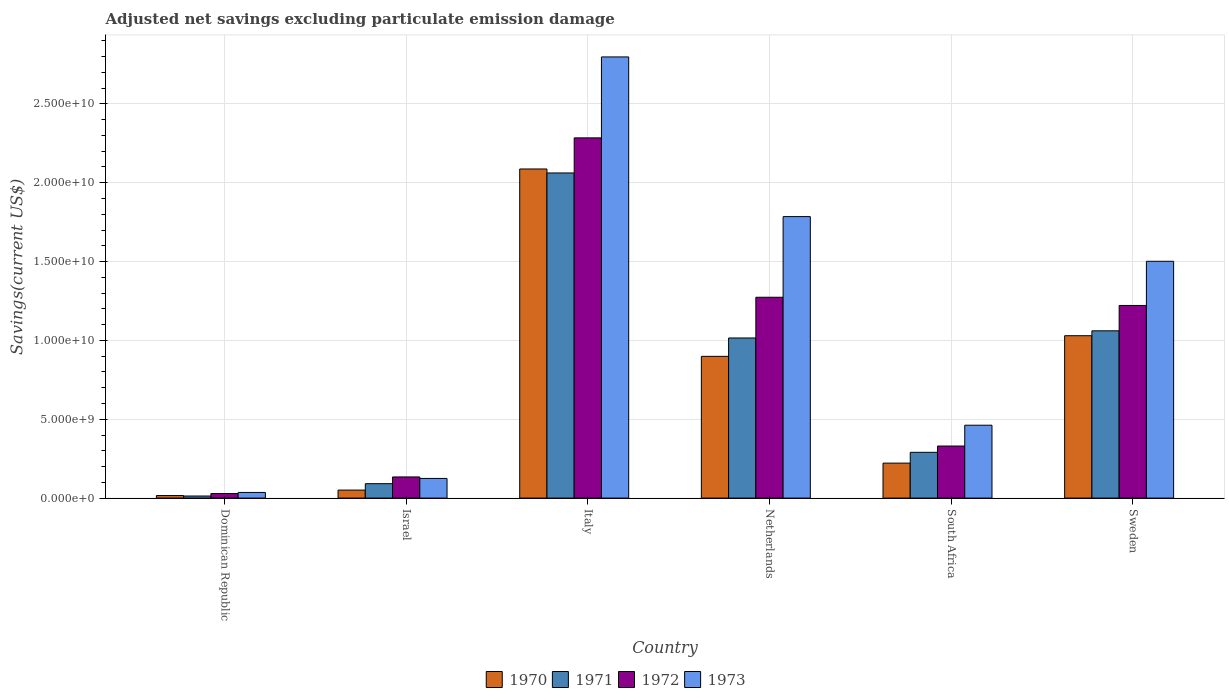How many different coloured bars are there?
Your response must be concise. 4. How many groups of bars are there?
Offer a terse response. 6. Are the number of bars on each tick of the X-axis equal?
Ensure brevity in your answer.  Yes. How many bars are there on the 2nd tick from the left?
Provide a succinct answer. 4. How many bars are there on the 4th tick from the right?
Offer a terse response. 4. What is the label of the 5th group of bars from the left?
Your answer should be very brief. South Africa. What is the adjusted net savings in 1970 in Netherlands?
Your answer should be compact. 8.99e+09. Across all countries, what is the maximum adjusted net savings in 1973?
Give a very brief answer. 2.80e+1. Across all countries, what is the minimum adjusted net savings in 1972?
Keep it short and to the point. 2.89e+08. In which country was the adjusted net savings in 1971 minimum?
Provide a succinct answer. Dominican Republic. What is the total adjusted net savings in 1973 in the graph?
Provide a short and direct response. 6.71e+1. What is the difference between the adjusted net savings in 1973 in Dominican Republic and that in Israel?
Your response must be concise. -8.89e+08. What is the difference between the adjusted net savings in 1972 in Dominican Republic and the adjusted net savings in 1971 in Israel?
Offer a very short reply. -6.26e+08. What is the average adjusted net savings in 1970 per country?
Ensure brevity in your answer.  7.17e+09. What is the difference between the adjusted net savings of/in 1973 and adjusted net savings of/in 1971 in Sweden?
Make the answer very short. 4.41e+09. In how many countries, is the adjusted net savings in 1973 greater than 13000000000 US$?
Your answer should be very brief. 3. What is the ratio of the adjusted net savings in 1970 in Italy to that in South Africa?
Give a very brief answer. 9.41. Is the adjusted net savings in 1971 in Italy less than that in South Africa?
Ensure brevity in your answer.  No. What is the difference between the highest and the second highest adjusted net savings in 1970?
Ensure brevity in your answer.  1.06e+1. What is the difference between the highest and the lowest adjusted net savings in 1972?
Keep it short and to the point. 2.26e+1. In how many countries, is the adjusted net savings in 1970 greater than the average adjusted net savings in 1970 taken over all countries?
Make the answer very short. 3. What does the 2nd bar from the left in Italy represents?
Your response must be concise. 1971. What does the 3rd bar from the right in Israel represents?
Offer a very short reply. 1971. Are all the bars in the graph horizontal?
Provide a short and direct response. No. How many countries are there in the graph?
Make the answer very short. 6. Does the graph contain any zero values?
Ensure brevity in your answer.  No. How are the legend labels stacked?
Keep it short and to the point. Horizontal. What is the title of the graph?
Provide a short and direct response. Adjusted net savings excluding particulate emission damage. What is the label or title of the Y-axis?
Offer a very short reply. Savings(current US$). What is the Savings(current US$) of 1970 in Dominican Republic?
Give a very brief answer. 1.61e+08. What is the Savings(current US$) in 1971 in Dominican Republic?
Make the answer very short. 1.32e+08. What is the Savings(current US$) in 1972 in Dominican Republic?
Your answer should be very brief. 2.89e+08. What is the Savings(current US$) of 1973 in Dominican Republic?
Your answer should be very brief. 3.58e+08. What is the Savings(current US$) of 1970 in Israel?
Make the answer very short. 5.08e+08. What is the Savings(current US$) of 1971 in Israel?
Keep it short and to the point. 9.14e+08. What is the Savings(current US$) of 1972 in Israel?
Offer a terse response. 1.34e+09. What is the Savings(current US$) in 1973 in Israel?
Keep it short and to the point. 1.25e+09. What is the Savings(current US$) in 1970 in Italy?
Ensure brevity in your answer.  2.09e+1. What is the Savings(current US$) in 1971 in Italy?
Keep it short and to the point. 2.06e+1. What is the Savings(current US$) of 1972 in Italy?
Your response must be concise. 2.28e+1. What is the Savings(current US$) of 1973 in Italy?
Give a very brief answer. 2.80e+1. What is the Savings(current US$) in 1970 in Netherlands?
Offer a terse response. 8.99e+09. What is the Savings(current US$) in 1971 in Netherlands?
Give a very brief answer. 1.02e+1. What is the Savings(current US$) of 1972 in Netherlands?
Offer a very short reply. 1.27e+1. What is the Savings(current US$) of 1973 in Netherlands?
Your response must be concise. 1.79e+1. What is the Savings(current US$) in 1970 in South Africa?
Provide a succinct answer. 2.22e+09. What is the Savings(current US$) of 1971 in South Africa?
Ensure brevity in your answer.  2.90e+09. What is the Savings(current US$) of 1972 in South Africa?
Ensure brevity in your answer.  3.30e+09. What is the Savings(current US$) in 1973 in South Africa?
Give a very brief answer. 4.62e+09. What is the Savings(current US$) of 1970 in Sweden?
Your response must be concise. 1.03e+1. What is the Savings(current US$) of 1971 in Sweden?
Give a very brief answer. 1.06e+1. What is the Savings(current US$) of 1972 in Sweden?
Your answer should be compact. 1.22e+1. What is the Savings(current US$) of 1973 in Sweden?
Give a very brief answer. 1.50e+1. Across all countries, what is the maximum Savings(current US$) in 1970?
Provide a short and direct response. 2.09e+1. Across all countries, what is the maximum Savings(current US$) in 1971?
Provide a short and direct response. 2.06e+1. Across all countries, what is the maximum Savings(current US$) of 1972?
Your response must be concise. 2.28e+1. Across all countries, what is the maximum Savings(current US$) of 1973?
Make the answer very short. 2.80e+1. Across all countries, what is the minimum Savings(current US$) of 1970?
Your answer should be very brief. 1.61e+08. Across all countries, what is the minimum Savings(current US$) of 1971?
Make the answer very short. 1.32e+08. Across all countries, what is the minimum Savings(current US$) in 1972?
Your response must be concise. 2.89e+08. Across all countries, what is the minimum Savings(current US$) in 1973?
Make the answer very short. 3.58e+08. What is the total Savings(current US$) of 1970 in the graph?
Provide a succinct answer. 4.30e+1. What is the total Savings(current US$) in 1971 in the graph?
Your answer should be compact. 4.53e+1. What is the total Savings(current US$) of 1972 in the graph?
Give a very brief answer. 5.27e+1. What is the total Savings(current US$) in 1973 in the graph?
Your answer should be compact. 6.71e+1. What is the difference between the Savings(current US$) of 1970 in Dominican Republic and that in Israel?
Offer a very short reply. -3.47e+08. What is the difference between the Savings(current US$) in 1971 in Dominican Republic and that in Israel?
Offer a very short reply. -7.83e+08. What is the difference between the Savings(current US$) in 1972 in Dominican Republic and that in Israel?
Provide a succinct answer. -1.05e+09. What is the difference between the Savings(current US$) of 1973 in Dominican Republic and that in Israel?
Keep it short and to the point. -8.89e+08. What is the difference between the Savings(current US$) of 1970 in Dominican Republic and that in Italy?
Your answer should be compact. -2.07e+1. What is the difference between the Savings(current US$) in 1971 in Dominican Republic and that in Italy?
Offer a terse response. -2.05e+1. What is the difference between the Savings(current US$) of 1972 in Dominican Republic and that in Italy?
Your answer should be compact. -2.26e+1. What is the difference between the Savings(current US$) of 1973 in Dominican Republic and that in Italy?
Provide a short and direct response. -2.76e+1. What is the difference between the Savings(current US$) of 1970 in Dominican Republic and that in Netherlands?
Give a very brief answer. -8.83e+09. What is the difference between the Savings(current US$) in 1971 in Dominican Republic and that in Netherlands?
Keep it short and to the point. -1.00e+1. What is the difference between the Savings(current US$) in 1972 in Dominican Republic and that in Netherlands?
Provide a succinct answer. -1.24e+1. What is the difference between the Savings(current US$) in 1973 in Dominican Republic and that in Netherlands?
Provide a short and direct response. -1.75e+1. What is the difference between the Savings(current US$) in 1970 in Dominican Republic and that in South Africa?
Give a very brief answer. -2.06e+09. What is the difference between the Savings(current US$) in 1971 in Dominican Republic and that in South Africa?
Your answer should be compact. -2.77e+09. What is the difference between the Savings(current US$) of 1972 in Dominican Republic and that in South Africa?
Offer a very short reply. -3.01e+09. What is the difference between the Savings(current US$) in 1973 in Dominican Republic and that in South Africa?
Ensure brevity in your answer.  -4.26e+09. What is the difference between the Savings(current US$) of 1970 in Dominican Republic and that in Sweden?
Make the answer very short. -1.01e+1. What is the difference between the Savings(current US$) of 1971 in Dominican Republic and that in Sweden?
Make the answer very short. -1.05e+1. What is the difference between the Savings(current US$) in 1972 in Dominican Republic and that in Sweden?
Ensure brevity in your answer.  -1.19e+1. What is the difference between the Savings(current US$) of 1973 in Dominican Republic and that in Sweden?
Provide a succinct answer. -1.47e+1. What is the difference between the Savings(current US$) in 1970 in Israel and that in Italy?
Provide a succinct answer. -2.04e+1. What is the difference between the Savings(current US$) of 1971 in Israel and that in Italy?
Give a very brief answer. -1.97e+1. What is the difference between the Savings(current US$) of 1972 in Israel and that in Italy?
Ensure brevity in your answer.  -2.15e+1. What is the difference between the Savings(current US$) of 1973 in Israel and that in Italy?
Offer a terse response. -2.67e+1. What is the difference between the Savings(current US$) in 1970 in Israel and that in Netherlands?
Ensure brevity in your answer.  -8.48e+09. What is the difference between the Savings(current US$) of 1971 in Israel and that in Netherlands?
Ensure brevity in your answer.  -9.24e+09. What is the difference between the Savings(current US$) in 1972 in Israel and that in Netherlands?
Provide a succinct answer. -1.14e+1. What is the difference between the Savings(current US$) in 1973 in Israel and that in Netherlands?
Your answer should be compact. -1.66e+1. What is the difference between the Savings(current US$) of 1970 in Israel and that in South Africa?
Provide a succinct answer. -1.71e+09. What is the difference between the Savings(current US$) in 1971 in Israel and that in South Africa?
Keep it short and to the point. -1.99e+09. What is the difference between the Savings(current US$) of 1972 in Israel and that in South Africa?
Provide a short and direct response. -1.96e+09. What is the difference between the Savings(current US$) of 1973 in Israel and that in South Africa?
Offer a terse response. -3.38e+09. What is the difference between the Savings(current US$) in 1970 in Israel and that in Sweden?
Give a very brief answer. -9.79e+09. What is the difference between the Savings(current US$) of 1971 in Israel and that in Sweden?
Provide a short and direct response. -9.69e+09. What is the difference between the Savings(current US$) in 1972 in Israel and that in Sweden?
Your answer should be compact. -1.09e+1. What is the difference between the Savings(current US$) in 1973 in Israel and that in Sweden?
Provide a short and direct response. -1.38e+1. What is the difference between the Savings(current US$) of 1970 in Italy and that in Netherlands?
Offer a terse response. 1.19e+1. What is the difference between the Savings(current US$) of 1971 in Italy and that in Netherlands?
Your answer should be very brief. 1.05e+1. What is the difference between the Savings(current US$) in 1972 in Italy and that in Netherlands?
Offer a terse response. 1.01e+1. What is the difference between the Savings(current US$) in 1973 in Italy and that in Netherlands?
Provide a succinct answer. 1.01e+1. What is the difference between the Savings(current US$) of 1970 in Italy and that in South Africa?
Offer a very short reply. 1.87e+1. What is the difference between the Savings(current US$) of 1971 in Italy and that in South Africa?
Make the answer very short. 1.77e+1. What is the difference between the Savings(current US$) in 1972 in Italy and that in South Africa?
Your response must be concise. 1.95e+1. What is the difference between the Savings(current US$) in 1973 in Italy and that in South Africa?
Offer a terse response. 2.34e+1. What is the difference between the Savings(current US$) in 1970 in Italy and that in Sweden?
Offer a very short reply. 1.06e+1. What is the difference between the Savings(current US$) in 1971 in Italy and that in Sweden?
Provide a succinct answer. 1.00e+1. What is the difference between the Savings(current US$) in 1972 in Italy and that in Sweden?
Offer a very short reply. 1.06e+1. What is the difference between the Savings(current US$) of 1973 in Italy and that in Sweden?
Your answer should be compact. 1.30e+1. What is the difference between the Savings(current US$) in 1970 in Netherlands and that in South Africa?
Your answer should be very brief. 6.77e+09. What is the difference between the Savings(current US$) of 1971 in Netherlands and that in South Africa?
Give a very brief answer. 7.25e+09. What is the difference between the Savings(current US$) of 1972 in Netherlands and that in South Africa?
Offer a terse response. 9.43e+09. What is the difference between the Savings(current US$) in 1973 in Netherlands and that in South Africa?
Keep it short and to the point. 1.32e+1. What is the difference between the Savings(current US$) in 1970 in Netherlands and that in Sweden?
Ensure brevity in your answer.  -1.31e+09. What is the difference between the Savings(current US$) in 1971 in Netherlands and that in Sweden?
Ensure brevity in your answer.  -4.54e+08. What is the difference between the Savings(current US$) in 1972 in Netherlands and that in Sweden?
Your answer should be very brief. 5.20e+08. What is the difference between the Savings(current US$) in 1973 in Netherlands and that in Sweden?
Your answer should be very brief. 2.83e+09. What is the difference between the Savings(current US$) of 1970 in South Africa and that in Sweden?
Your answer should be very brief. -8.08e+09. What is the difference between the Savings(current US$) of 1971 in South Africa and that in Sweden?
Provide a short and direct response. -7.70e+09. What is the difference between the Savings(current US$) in 1972 in South Africa and that in Sweden?
Ensure brevity in your answer.  -8.91e+09. What is the difference between the Savings(current US$) in 1973 in South Africa and that in Sweden?
Offer a terse response. -1.04e+1. What is the difference between the Savings(current US$) in 1970 in Dominican Republic and the Savings(current US$) in 1971 in Israel?
Your answer should be very brief. -7.53e+08. What is the difference between the Savings(current US$) of 1970 in Dominican Republic and the Savings(current US$) of 1972 in Israel?
Your answer should be compact. -1.18e+09. What is the difference between the Savings(current US$) of 1970 in Dominican Republic and the Savings(current US$) of 1973 in Israel?
Keep it short and to the point. -1.09e+09. What is the difference between the Savings(current US$) in 1971 in Dominican Republic and the Savings(current US$) in 1972 in Israel?
Your response must be concise. -1.21e+09. What is the difference between the Savings(current US$) of 1971 in Dominican Republic and the Savings(current US$) of 1973 in Israel?
Your answer should be very brief. -1.12e+09. What is the difference between the Savings(current US$) of 1972 in Dominican Republic and the Savings(current US$) of 1973 in Israel?
Give a very brief answer. -9.58e+08. What is the difference between the Savings(current US$) in 1970 in Dominican Republic and the Savings(current US$) in 1971 in Italy?
Offer a terse response. -2.05e+1. What is the difference between the Savings(current US$) of 1970 in Dominican Republic and the Savings(current US$) of 1972 in Italy?
Your answer should be compact. -2.27e+1. What is the difference between the Savings(current US$) in 1970 in Dominican Republic and the Savings(current US$) in 1973 in Italy?
Your response must be concise. -2.78e+1. What is the difference between the Savings(current US$) in 1971 in Dominican Republic and the Savings(current US$) in 1972 in Italy?
Your answer should be compact. -2.27e+1. What is the difference between the Savings(current US$) in 1971 in Dominican Republic and the Savings(current US$) in 1973 in Italy?
Your response must be concise. -2.78e+1. What is the difference between the Savings(current US$) of 1972 in Dominican Republic and the Savings(current US$) of 1973 in Italy?
Make the answer very short. -2.77e+1. What is the difference between the Savings(current US$) of 1970 in Dominican Republic and the Savings(current US$) of 1971 in Netherlands?
Provide a short and direct response. -9.99e+09. What is the difference between the Savings(current US$) in 1970 in Dominican Republic and the Savings(current US$) in 1972 in Netherlands?
Ensure brevity in your answer.  -1.26e+1. What is the difference between the Savings(current US$) of 1970 in Dominican Republic and the Savings(current US$) of 1973 in Netherlands?
Make the answer very short. -1.77e+1. What is the difference between the Savings(current US$) of 1971 in Dominican Republic and the Savings(current US$) of 1972 in Netherlands?
Your response must be concise. -1.26e+1. What is the difference between the Savings(current US$) of 1971 in Dominican Republic and the Savings(current US$) of 1973 in Netherlands?
Provide a succinct answer. -1.77e+1. What is the difference between the Savings(current US$) of 1972 in Dominican Republic and the Savings(current US$) of 1973 in Netherlands?
Offer a terse response. -1.76e+1. What is the difference between the Savings(current US$) in 1970 in Dominican Republic and the Savings(current US$) in 1971 in South Africa?
Offer a very short reply. -2.74e+09. What is the difference between the Savings(current US$) of 1970 in Dominican Republic and the Savings(current US$) of 1972 in South Africa?
Offer a terse response. -3.14e+09. What is the difference between the Savings(current US$) in 1970 in Dominican Republic and the Savings(current US$) in 1973 in South Africa?
Offer a terse response. -4.46e+09. What is the difference between the Savings(current US$) in 1971 in Dominican Republic and the Savings(current US$) in 1972 in South Africa?
Your response must be concise. -3.17e+09. What is the difference between the Savings(current US$) of 1971 in Dominican Republic and the Savings(current US$) of 1973 in South Africa?
Give a very brief answer. -4.49e+09. What is the difference between the Savings(current US$) of 1972 in Dominican Republic and the Savings(current US$) of 1973 in South Africa?
Make the answer very short. -4.33e+09. What is the difference between the Savings(current US$) of 1970 in Dominican Republic and the Savings(current US$) of 1971 in Sweden?
Offer a terse response. -1.04e+1. What is the difference between the Savings(current US$) of 1970 in Dominican Republic and the Savings(current US$) of 1972 in Sweden?
Your response must be concise. -1.21e+1. What is the difference between the Savings(current US$) of 1970 in Dominican Republic and the Savings(current US$) of 1973 in Sweden?
Your response must be concise. -1.49e+1. What is the difference between the Savings(current US$) in 1971 in Dominican Republic and the Savings(current US$) in 1972 in Sweden?
Ensure brevity in your answer.  -1.21e+1. What is the difference between the Savings(current US$) of 1971 in Dominican Republic and the Savings(current US$) of 1973 in Sweden?
Keep it short and to the point. -1.49e+1. What is the difference between the Savings(current US$) in 1972 in Dominican Republic and the Savings(current US$) in 1973 in Sweden?
Offer a terse response. -1.47e+1. What is the difference between the Savings(current US$) in 1970 in Israel and the Savings(current US$) in 1971 in Italy?
Your response must be concise. -2.01e+1. What is the difference between the Savings(current US$) in 1970 in Israel and the Savings(current US$) in 1972 in Italy?
Your response must be concise. -2.23e+1. What is the difference between the Savings(current US$) in 1970 in Israel and the Savings(current US$) in 1973 in Italy?
Keep it short and to the point. -2.75e+1. What is the difference between the Savings(current US$) in 1971 in Israel and the Savings(current US$) in 1972 in Italy?
Make the answer very short. -2.19e+1. What is the difference between the Savings(current US$) in 1971 in Israel and the Savings(current US$) in 1973 in Italy?
Give a very brief answer. -2.71e+1. What is the difference between the Savings(current US$) of 1972 in Israel and the Savings(current US$) of 1973 in Italy?
Your answer should be compact. -2.66e+1. What is the difference between the Savings(current US$) in 1970 in Israel and the Savings(current US$) in 1971 in Netherlands?
Offer a terse response. -9.65e+09. What is the difference between the Savings(current US$) in 1970 in Israel and the Savings(current US$) in 1972 in Netherlands?
Your response must be concise. -1.22e+1. What is the difference between the Savings(current US$) of 1970 in Israel and the Savings(current US$) of 1973 in Netherlands?
Make the answer very short. -1.73e+1. What is the difference between the Savings(current US$) of 1971 in Israel and the Savings(current US$) of 1972 in Netherlands?
Offer a very short reply. -1.18e+1. What is the difference between the Savings(current US$) in 1971 in Israel and the Savings(current US$) in 1973 in Netherlands?
Offer a terse response. -1.69e+1. What is the difference between the Savings(current US$) of 1972 in Israel and the Savings(current US$) of 1973 in Netherlands?
Offer a very short reply. -1.65e+1. What is the difference between the Savings(current US$) of 1970 in Israel and the Savings(current US$) of 1971 in South Africa?
Ensure brevity in your answer.  -2.39e+09. What is the difference between the Savings(current US$) of 1970 in Israel and the Savings(current US$) of 1972 in South Africa?
Provide a short and direct response. -2.79e+09. What is the difference between the Savings(current US$) of 1970 in Israel and the Savings(current US$) of 1973 in South Africa?
Make the answer very short. -4.11e+09. What is the difference between the Savings(current US$) of 1971 in Israel and the Savings(current US$) of 1972 in South Africa?
Ensure brevity in your answer.  -2.39e+09. What is the difference between the Savings(current US$) in 1971 in Israel and the Savings(current US$) in 1973 in South Africa?
Your answer should be compact. -3.71e+09. What is the difference between the Savings(current US$) of 1972 in Israel and the Savings(current US$) of 1973 in South Africa?
Keep it short and to the point. -3.28e+09. What is the difference between the Savings(current US$) of 1970 in Israel and the Savings(current US$) of 1971 in Sweden?
Provide a short and direct response. -1.01e+1. What is the difference between the Savings(current US$) in 1970 in Israel and the Savings(current US$) in 1972 in Sweden?
Provide a succinct answer. -1.17e+1. What is the difference between the Savings(current US$) of 1970 in Israel and the Savings(current US$) of 1973 in Sweden?
Give a very brief answer. -1.45e+1. What is the difference between the Savings(current US$) of 1971 in Israel and the Savings(current US$) of 1972 in Sweden?
Offer a terse response. -1.13e+1. What is the difference between the Savings(current US$) in 1971 in Israel and the Savings(current US$) in 1973 in Sweden?
Provide a short and direct response. -1.41e+1. What is the difference between the Savings(current US$) in 1972 in Israel and the Savings(current US$) in 1973 in Sweden?
Give a very brief answer. -1.37e+1. What is the difference between the Savings(current US$) in 1970 in Italy and the Savings(current US$) in 1971 in Netherlands?
Provide a succinct answer. 1.07e+1. What is the difference between the Savings(current US$) of 1970 in Italy and the Savings(current US$) of 1972 in Netherlands?
Offer a terse response. 8.14e+09. What is the difference between the Savings(current US$) of 1970 in Italy and the Savings(current US$) of 1973 in Netherlands?
Make the answer very short. 3.02e+09. What is the difference between the Savings(current US$) in 1971 in Italy and the Savings(current US$) in 1972 in Netherlands?
Your answer should be compact. 7.88e+09. What is the difference between the Savings(current US$) of 1971 in Italy and the Savings(current US$) of 1973 in Netherlands?
Provide a succinct answer. 2.77e+09. What is the difference between the Savings(current US$) of 1972 in Italy and the Savings(current US$) of 1973 in Netherlands?
Offer a terse response. 4.99e+09. What is the difference between the Savings(current US$) of 1970 in Italy and the Savings(current US$) of 1971 in South Africa?
Keep it short and to the point. 1.80e+1. What is the difference between the Savings(current US$) in 1970 in Italy and the Savings(current US$) in 1972 in South Africa?
Ensure brevity in your answer.  1.76e+1. What is the difference between the Savings(current US$) in 1970 in Italy and the Savings(current US$) in 1973 in South Africa?
Keep it short and to the point. 1.62e+1. What is the difference between the Savings(current US$) in 1971 in Italy and the Savings(current US$) in 1972 in South Africa?
Your answer should be very brief. 1.73e+1. What is the difference between the Savings(current US$) of 1971 in Italy and the Savings(current US$) of 1973 in South Africa?
Offer a very short reply. 1.60e+1. What is the difference between the Savings(current US$) of 1972 in Italy and the Savings(current US$) of 1973 in South Africa?
Make the answer very short. 1.82e+1. What is the difference between the Savings(current US$) of 1970 in Italy and the Savings(current US$) of 1971 in Sweden?
Make the answer very short. 1.03e+1. What is the difference between the Savings(current US$) of 1970 in Italy and the Savings(current US$) of 1972 in Sweden?
Your answer should be compact. 8.66e+09. What is the difference between the Savings(current US$) in 1970 in Italy and the Savings(current US$) in 1973 in Sweden?
Provide a succinct answer. 5.85e+09. What is the difference between the Savings(current US$) in 1971 in Italy and the Savings(current US$) in 1972 in Sweden?
Make the answer very short. 8.40e+09. What is the difference between the Savings(current US$) in 1971 in Italy and the Savings(current US$) in 1973 in Sweden?
Offer a terse response. 5.60e+09. What is the difference between the Savings(current US$) of 1972 in Italy and the Savings(current US$) of 1973 in Sweden?
Your answer should be very brief. 7.83e+09. What is the difference between the Savings(current US$) in 1970 in Netherlands and the Savings(current US$) in 1971 in South Africa?
Make the answer very short. 6.09e+09. What is the difference between the Savings(current US$) in 1970 in Netherlands and the Savings(current US$) in 1972 in South Africa?
Your response must be concise. 5.69e+09. What is the difference between the Savings(current US$) in 1970 in Netherlands and the Savings(current US$) in 1973 in South Africa?
Your response must be concise. 4.37e+09. What is the difference between the Savings(current US$) in 1971 in Netherlands and the Savings(current US$) in 1972 in South Africa?
Give a very brief answer. 6.85e+09. What is the difference between the Savings(current US$) of 1971 in Netherlands and the Savings(current US$) of 1973 in South Africa?
Your answer should be compact. 5.53e+09. What is the difference between the Savings(current US$) in 1972 in Netherlands and the Savings(current US$) in 1973 in South Africa?
Ensure brevity in your answer.  8.11e+09. What is the difference between the Savings(current US$) of 1970 in Netherlands and the Savings(current US$) of 1971 in Sweden?
Make the answer very short. -1.62e+09. What is the difference between the Savings(current US$) in 1970 in Netherlands and the Savings(current US$) in 1972 in Sweden?
Provide a succinct answer. -3.23e+09. What is the difference between the Savings(current US$) in 1970 in Netherlands and the Savings(current US$) in 1973 in Sweden?
Your answer should be very brief. -6.03e+09. What is the difference between the Savings(current US$) in 1971 in Netherlands and the Savings(current US$) in 1972 in Sweden?
Ensure brevity in your answer.  -2.06e+09. What is the difference between the Savings(current US$) of 1971 in Netherlands and the Savings(current US$) of 1973 in Sweden?
Offer a very short reply. -4.86e+09. What is the difference between the Savings(current US$) of 1972 in Netherlands and the Savings(current US$) of 1973 in Sweden?
Your response must be concise. -2.28e+09. What is the difference between the Savings(current US$) of 1970 in South Africa and the Savings(current US$) of 1971 in Sweden?
Offer a terse response. -8.39e+09. What is the difference between the Savings(current US$) of 1970 in South Africa and the Savings(current US$) of 1972 in Sweden?
Provide a succinct answer. -1.00e+1. What is the difference between the Savings(current US$) in 1970 in South Africa and the Savings(current US$) in 1973 in Sweden?
Your answer should be compact. -1.28e+1. What is the difference between the Savings(current US$) in 1971 in South Africa and the Savings(current US$) in 1972 in Sweden?
Provide a succinct answer. -9.31e+09. What is the difference between the Savings(current US$) of 1971 in South Africa and the Savings(current US$) of 1973 in Sweden?
Offer a terse response. -1.21e+1. What is the difference between the Savings(current US$) in 1972 in South Africa and the Savings(current US$) in 1973 in Sweden?
Your answer should be very brief. -1.17e+1. What is the average Savings(current US$) of 1970 per country?
Give a very brief answer. 7.17e+09. What is the average Savings(current US$) in 1971 per country?
Make the answer very short. 7.55e+09. What is the average Savings(current US$) of 1972 per country?
Give a very brief answer. 8.79e+09. What is the average Savings(current US$) in 1973 per country?
Provide a succinct answer. 1.12e+1. What is the difference between the Savings(current US$) in 1970 and Savings(current US$) in 1971 in Dominican Republic?
Your answer should be compact. 2.96e+07. What is the difference between the Savings(current US$) of 1970 and Savings(current US$) of 1972 in Dominican Republic?
Keep it short and to the point. -1.28e+08. What is the difference between the Savings(current US$) of 1970 and Savings(current US$) of 1973 in Dominican Republic?
Make the answer very short. -1.97e+08. What is the difference between the Savings(current US$) in 1971 and Savings(current US$) in 1972 in Dominican Republic?
Your answer should be compact. -1.57e+08. What is the difference between the Savings(current US$) of 1971 and Savings(current US$) of 1973 in Dominican Republic?
Ensure brevity in your answer.  -2.27e+08. What is the difference between the Savings(current US$) in 1972 and Savings(current US$) in 1973 in Dominican Republic?
Provide a short and direct response. -6.95e+07. What is the difference between the Savings(current US$) of 1970 and Savings(current US$) of 1971 in Israel?
Your answer should be very brief. -4.06e+08. What is the difference between the Savings(current US$) of 1970 and Savings(current US$) of 1972 in Israel?
Your answer should be compact. -8.33e+08. What is the difference between the Savings(current US$) of 1970 and Savings(current US$) of 1973 in Israel?
Offer a very short reply. -7.39e+08. What is the difference between the Savings(current US$) in 1971 and Savings(current US$) in 1972 in Israel?
Your response must be concise. -4.27e+08. What is the difference between the Savings(current US$) of 1971 and Savings(current US$) of 1973 in Israel?
Provide a short and direct response. -3.33e+08. What is the difference between the Savings(current US$) in 1972 and Savings(current US$) in 1973 in Israel?
Provide a short and direct response. 9.40e+07. What is the difference between the Savings(current US$) of 1970 and Savings(current US$) of 1971 in Italy?
Provide a short and direct response. 2.53e+08. What is the difference between the Savings(current US$) of 1970 and Savings(current US$) of 1972 in Italy?
Your answer should be very brief. -1.97e+09. What is the difference between the Savings(current US$) in 1970 and Savings(current US$) in 1973 in Italy?
Ensure brevity in your answer.  -7.11e+09. What is the difference between the Savings(current US$) of 1971 and Savings(current US$) of 1972 in Italy?
Provide a short and direct response. -2.23e+09. What is the difference between the Savings(current US$) in 1971 and Savings(current US$) in 1973 in Italy?
Give a very brief answer. -7.36e+09. What is the difference between the Savings(current US$) in 1972 and Savings(current US$) in 1973 in Italy?
Your answer should be very brief. -5.13e+09. What is the difference between the Savings(current US$) in 1970 and Savings(current US$) in 1971 in Netherlands?
Your answer should be compact. -1.17e+09. What is the difference between the Savings(current US$) of 1970 and Savings(current US$) of 1972 in Netherlands?
Make the answer very short. -3.75e+09. What is the difference between the Savings(current US$) in 1970 and Savings(current US$) in 1973 in Netherlands?
Make the answer very short. -8.86e+09. What is the difference between the Savings(current US$) of 1971 and Savings(current US$) of 1972 in Netherlands?
Provide a short and direct response. -2.58e+09. What is the difference between the Savings(current US$) of 1971 and Savings(current US$) of 1973 in Netherlands?
Ensure brevity in your answer.  -7.70e+09. What is the difference between the Savings(current US$) in 1972 and Savings(current US$) in 1973 in Netherlands?
Keep it short and to the point. -5.11e+09. What is the difference between the Savings(current US$) in 1970 and Savings(current US$) in 1971 in South Africa?
Offer a terse response. -6.85e+08. What is the difference between the Savings(current US$) in 1970 and Savings(current US$) in 1972 in South Africa?
Make the answer very short. -1.08e+09. What is the difference between the Savings(current US$) of 1970 and Savings(current US$) of 1973 in South Africa?
Your answer should be compact. -2.40e+09. What is the difference between the Savings(current US$) in 1971 and Savings(current US$) in 1972 in South Africa?
Offer a very short reply. -4.00e+08. What is the difference between the Savings(current US$) in 1971 and Savings(current US$) in 1973 in South Africa?
Your response must be concise. -1.72e+09. What is the difference between the Savings(current US$) in 1972 and Savings(current US$) in 1973 in South Africa?
Make the answer very short. -1.32e+09. What is the difference between the Savings(current US$) of 1970 and Savings(current US$) of 1971 in Sweden?
Provide a succinct answer. -3.10e+08. What is the difference between the Savings(current US$) in 1970 and Savings(current US$) in 1972 in Sweden?
Provide a succinct answer. -1.92e+09. What is the difference between the Savings(current US$) in 1970 and Savings(current US$) in 1973 in Sweden?
Give a very brief answer. -4.72e+09. What is the difference between the Savings(current US$) in 1971 and Savings(current US$) in 1972 in Sweden?
Offer a very short reply. -1.61e+09. What is the difference between the Savings(current US$) of 1971 and Savings(current US$) of 1973 in Sweden?
Your answer should be very brief. -4.41e+09. What is the difference between the Savings(current US$) of 1972 and Savings(current US$) of 1973 in Sweden?
Your answer should be compact. -2.80e+09. What is the ratio of the Savings(current US$) in 1970 in Dominican Republic to that in Israel?
Your answer should be compact. 0.32. What is the ratio of the Savings(current US$) in 1971 in Dominican Republic to that in Israel?
Offer a terse response. 0.14. What is the ratio of the Savings(current US$) in 1972 in Dominican Republic to that in Israel?
Ensure brevity in your answer.  0.22. What is the ratio of the Savings(current US$) in 1973 in Dominican Republic to that in Israel?
Provide a short and direct response. 0.29. What is the ratio of the Savings(current US$) in 1970 in Dominican Republic to that in Italy?
Provide a short and direct response. 0.01. What is the ratio of the Savings(current US$) in 1971 in Dominican Republic to that in Italy?
Provide a succinct answer. 0.01. What is the ratio of the Savings(current US$) in 1972 in Dominican Republic to that in Italy?
Give a very brief answer. 0.01. What is the ratio of the Savings(current US$) of 1973 in Dominican Republic to that in Italy?
Provide a short and direct response. 0.01. What is the ratio of the Savings(current US$) in 1970 in Dominican Republic to that in Netherlands?
Provide a succinct answer. 0.02. What is the ratio of the Savings(current US$) of 1971 in Dominican Republic to that in Netherlands?
Your response must be concise. 0.01. What is the ratio of the Savings(current US$) in 1972 in Dominican Republic to that in Netherlands?
Offer a very short reply. 0.02. What is the ratio of the Savings(current US$) in 1973 in Dominican Republic to that in Netherlands?
Provide a succinct answer. 0.02. What is the ratio of the Savings(current US$) of 1970 in Dominican Republic to that in South Africa?
Offer a very short reply. 0.07. What is the ratio of the Savings(current US$) of 1971 in Dominican Republic to that in South Africa?
Give a very brief answer. 0.05. What is the ratio of the Savings(current US$) in 1972 in Dominican Republic to that in South Africa?
Your response must be concise. 0.09. What is the ratio of the Savings(current US$) of 1973 in Dominican Republic to that in South Africa?
Your response must be concise. 0.08. What is the ratio of the Savings(current US$) in 1970 in Dominican Republic to that in Sweden?
Offer a terse response. 0.02. What is the ratio of the Savings(current US$) of 1971 in Dominican Republic to that in Sweden?
Make the answer very short. 0.01. What is the ratio of the Savings(current US$) of 1972 in Dominican Republic to that in Sweden?
Provide a short and direct response. 0.02. What is the ratio of the Savings(current US$) in 1973 in Dominican Republic to that in Sweden?
Give a very brief answer. 0.02. What is the ratio of the Savings(current US$) in 1970 in Israel to that in Italy?
Ensure brevity in your answer.  0.02. What is the ratio of the Savings(current US$) in 1971 in Israel to that in Italy?
Your answer should be very brief. 0.04. What is the ratio of the Savings(current US$) of 1972 in Israel to that in Italy?
Keep it short and to the point. 0.06. What is the ratio of the Savings(current US$) in 1973 in Israel to that in Italy?
Your response must be concise. 0.04. What is the ratio of the Savings(current US$) of 1970 in Israel to that in Netherlands?
Provide a short and direct response. 0.06. What is the ratio of the Savings(current US$) of 1971 in Israel to that in Netherlands?
Ensure brevity in your answer.  0.09. What is the ratio of the Savings(current US$) in 1972 in Israel to that in Netherlands?
Offer a very short reply. 0.11. What is the ratio of the Savings(current US$) of 1973 in Israel to that in Netherlands?
Offer a very short reply. 0.07. What is the ratio of the Savings(current US$) in 1970 in Israel to that in South Africa?
Offer a terse response. 0.23. What is the ratio of the Savings(current US$) in 1971 in Israel to that in South Africa?
Your answer should be very brief. 0.32. What is the ratio of the Savings(current US$) in 1972 in Israel to that in South Africa?
Provide a short and direct response. 0.41. What is the ratio of the Savings(current US$) in 1973 in Israel to that in South Africa?
Offer a terse response. 0.27. What is the ratio of the Savings(current US$) of 1970 in Israel to that in Sweden?
Your response must be concise. 0.05. What is the ratio of the Savings(current US$) of 1971 in Israel to that in Sweden?
Your response must be concise. 0.09. What is the ratio of the Savings(current US$) of 1972 in Israel to that in Sweden?
Your answer should be compact. 0.11. What is the ratio of the Savings(current US$) of 1973 in Israel to that in Sweden?
Make the answer very short. 0.08. What is the ratio of the Savings(current US$) of 1970 in Italy to that in Netherlands?
Provide a short and direct response. 2.32. What is the ratio of the Savings(current US$) in 1971 in Italy to that in Netherlands?
Make the answer very short. 2.03. What is the ratio of the Savings(current US$) in 1972 in Italy to that in Netherlands?
Keep it short and to the point. 1.79. What is the ratio of the Savings(current US$) of 1973 in Italy to that in Netherlands?
Your answer should be very brief. 1.57. What is the ratio of the Savings(current US$) of 1970 in Italy to that in South Africa?
Give a very brief answer. 9.41. What is the ratio of the Savings(current US$) in 1971 in Italy to that in South Africa?
Give a very brief answer. 7.1. What is the ratio of the Savings(current US$) of 1972 in Italy to that in South Africa?
Provide a succinct answer. 6.92. What is the ratio of the Savings(current US$) in 1973 in Italy to that in South Africa?
Offer a very short reply. 6.05. What is the ratio of the Savings(current US$) in 1970 in Italy to that in Sweden?
Offer a very short reply. 2.03. What is the ratio of the Savings(current US$) of 1971 in Italy to that in Sweden?
Offer a terse response. 1.94. What is the ratio of the Savings(current US$) of 1972 in Italy to that in Sweden?
Your answer should be very brief. 1.87. What is the ratio of the Savings(current US$) of 1973 in Italy to that in Sweden?
Make the answer very short. 1.86. What is the ratio of the Savings(current US$) of 1970 in Netherlands to that in South Africa?
Provide a short and direct response. 4.05. What is the ratio of the Savings(current US$) of 1971 in Netherlands to that in South Africa?
Keep it short and to the point. 3.5. What is the ratio of the Savings(current US$) in 1972 in Netherlands to that in South Africa?
Your answer should be compact. 3.86. What is the ratio of the Savings(current US$) in 1973 in Netherlands to that in South Africa?
Your response must be concise. 3.86. What is the ratio of the Savings(current US$) of 1970 in Netherlands to that in Sweden?
Provide a short and direct response. 0.87. What is the ratio of the Savings(current US$) of 1971 in Netherlands to that in Sweden?
Your answer should be compact. 0.96. What is the ratio of the Savings(current US$) of 1972 in Netherlands to that in Sweden?
Ensure brevity in your answer.  1.04. What is the ratio of the Savings(current US$) of 1973 in Netherlands to that in Sweden?
Your answer should be compact. 1.19. What is the ratio of the Savings(current US$) in 1970 in South Africa to that in Sweden?
Give a very brief answer. 0.22. What is the ratio of the Savings(current US$) of 1971 in South Africa to that in Sweden?
Ensure brevity in your answer.  0.27. What is the ratio of the Savings(current US$) of 1972 in South Africa to that in Sweden?
Give a very brief answer. 0.27. What is the ratio of the Savings(current US$) in 1973 in South Africa to that in Sweden?
Ensure brevity in your answer.  0.31. What is the difference between the highest and the second highest Savings(current US$) in 1970?
Give a very brief answer. 1.06e+1. What is the difference between the highest and the second highest Savings(current US$) of 1971?
Keep it short and to the point. 1.00e+1. What is the difference between the highest and the second highest Savings(current US$) in 1972?
Your answer should be very brief. 1.01e+1. What is the difference between the highest and the second highest Savings(current US$) of 1973?
Ensure brevity in your answer.  1.01e+1. What is the difference between the highest and the lowest Savings(current US$) in 1970?
Offer a very short reply. 2.07e+1. What is the difference between the highest and the lowest Savings(current US$) of 1971?
Keep it short and to the point. 2.05e+1. What is the difference between the highest and the lowest Savings(current US$) in 1972?
Ensure brevity in your answer.  2.26e+1. What is the difference between the highest and the lowest Savings(current US$) in 1973?
Ensure brevity in your answer.  2.76e+1. 